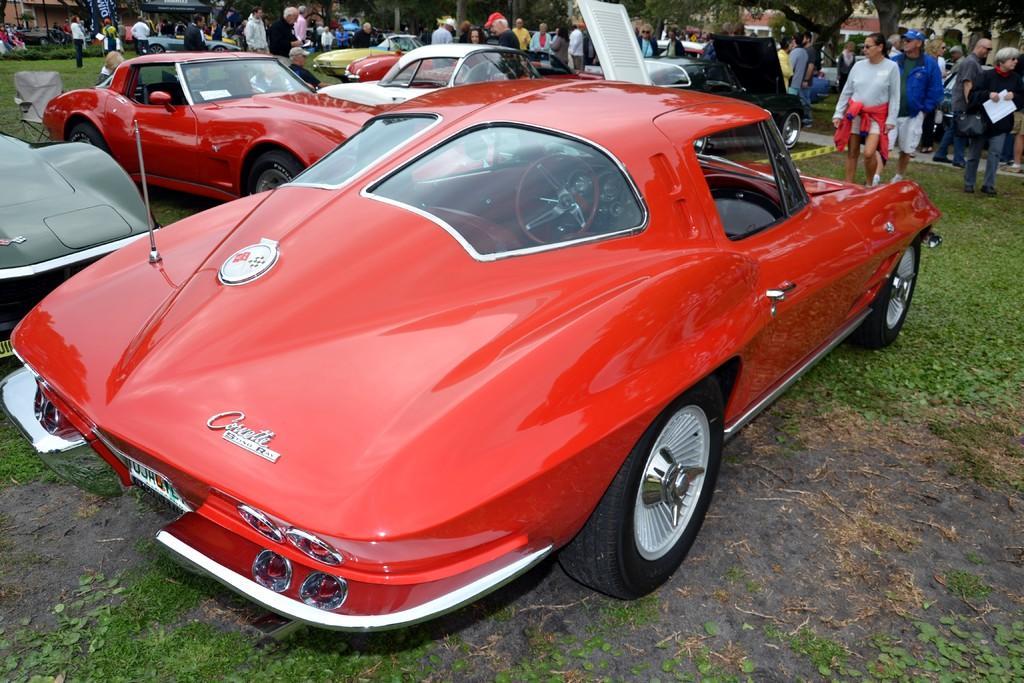In one or two sentences, can you explain what this image depicts? In this image we can see many vehicles. There are many trees and buildings in the image. There is a grassy land in the image. There are many people in the image. 